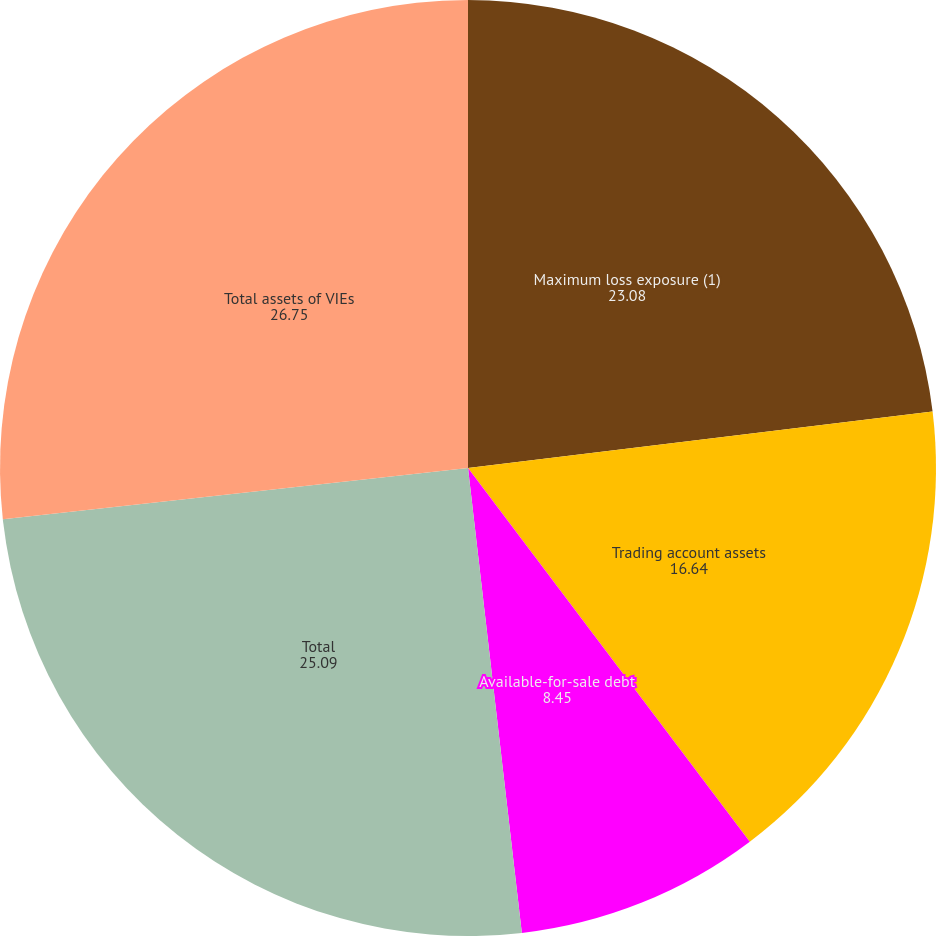Convert chart to OTSL. <chart><loc_0><loc_0><loc_500><loc_500><pie_chart><fcel>Maximum loss exposure (1)<fcel>Trading account assets<fcel>Available-for-sale debt<fcel>Total<fcel>Total assets of VIEs<nl><fcel>23.08%<fcel>16.64%<fcel>8.45%<fcel>25.09%<fcel>26.75%<nl></chart> 